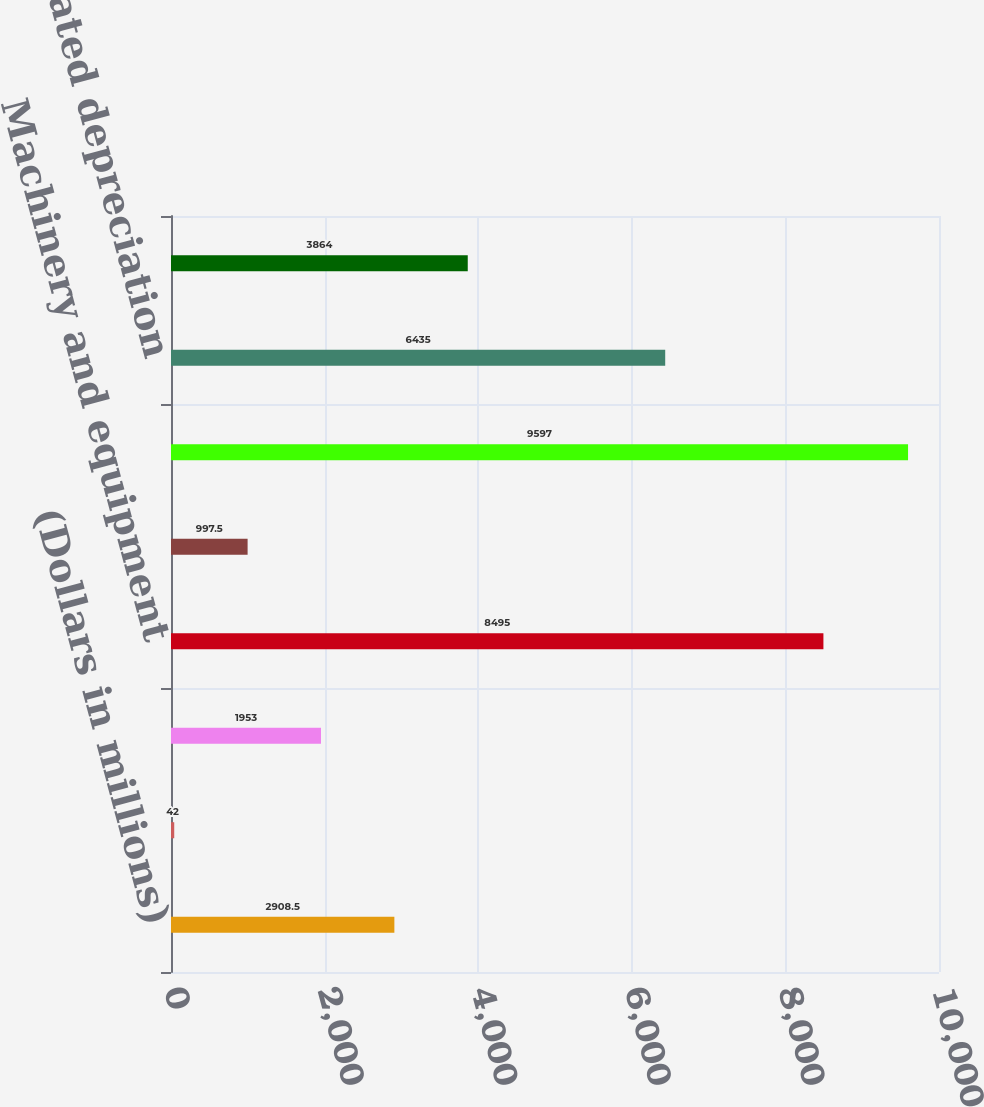<chart> <loc_0><loc_0><loc_500><loc_500><bar_chart><fcel>(Dollars in millions)<fcel>Land<fcel>Buildings and building<fcel>Machinery and equipment<fcel>Construction in progress<fcel>Properties and equipment at<fcel>Less Accumulated depreciation<fcel>Net properties<nl><fcel>2908.5<fcel>42<fcel>1953<fcel>8495<fcel>997.5<fcel>9597<fcel>6435<fcel>3864<nl></chart> 